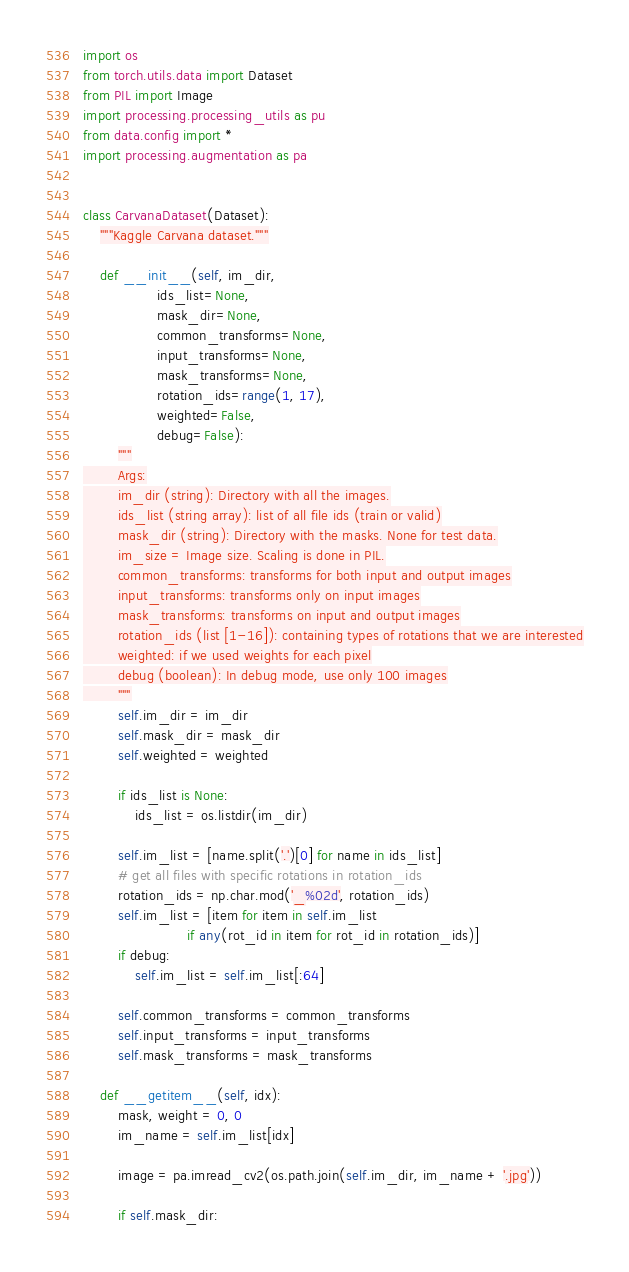<code> <loc_0><loc_0><loc_500><loc_500><_Python_>import os
from torch.utils.data import Dataset
from PIL import Image
import processing.processing_utils as pu
from data.config import *
import processing.augmentation as pa


class CarvanaDataset(Dataset):
    """Kaggle Carvana dataset."""

    def __init__(self, im_dir,
                 ids_list=None,
                 mask_dir=None,
                 common_transforms=None,
                 input_transforms=None,
                 mask_transforms=None,
                 rotation_ids=range(1, 17),
                 weighted=False,
                 debug=False):
        """
        Args:
        im_dir (string): Directory with all the images.
        ids_list (string array): list of all file ids (train or valid)
        mask_dir (string): Directory with the masks. None for test data.
        im_size = Image size. Scaling is done in PIL.
        common_transforms: transforms for both input and output images
        input_transforms: transforms only on input images
        mask_transforms: transforms on input and output images
        rotation_ids (list [1-16]): containing types of rotations that we are interested
        weighted: if we used weights for each pixel
        debug (boolean): In debug mode, use only 100 images
        """
        self.im_dir = im_dir
        self.mask_dir = mask_dir
        self.weighted = weighted

        if ids_list is None:
            ids_list = os.listdir(im_dir)

        self.im_list = [name.split('.')[0] for name in ids_list]
        # get all files with specific rotations in rotation_ids
        rotation_ids = np.char.mod('_%02d', rotation_ids)
        self.im_list = [item for item in self.im_list
                        if any(rot_id in item for rot_id in rotation_ids)]
        if debug:
            self.im_list = self.im_list[:64]

        self.common_transforms = common_transforms
        self.input_transforms = input_transforms
        self.mask_transforms = mask_transforms

    def __getitem__(self, idx):
        mask, weight = 0, 0
        im_name = self.im_list[idx]

        image = pa.imread_cv2(os.path.join(self.im_dir, im_name + '.jpg'))

        if self.mask_dir:</code> 